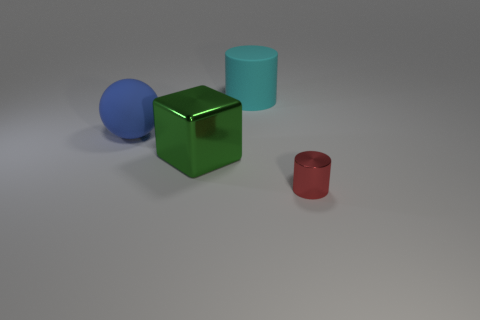Are there any large cylinders right of the big cylinder?
Offer a very short reply. No. What material is the large thing that is behind the green thing and in front of the cyan matte cylinder?
Keep it short and to the point. Rubber. There is a metal thing that is the same shape as the cyan matte object; what color is it?
Provide a succinct answer. Red. There is a big rubber thing that is in front of the cyan rubber cylinder; are there any rubber objects to the right of it?
Keep it short and to the point. Yes. What is the size of the green cube?
Keep it short and to the point. Large. The object that is both right of the large green cube and to the left of the tiny red metallic object has what shape?
Your answer should be very brief. Cylinder. What number of brown things are rubber things or tiny things?
Provide a short and direct response. 0. There is a rubber thing on the left side of the cyan rubber cylinder; is its size the same as the thing that is right of the big cyan matte cylinder?
Your answer should be compact. No. How many objects are metal cylinders or large blocks?
Your answer should be very brief. 2. Is there a blue rubber object of the same shape as the green metal thing?
Provide a succinct answer. No. 